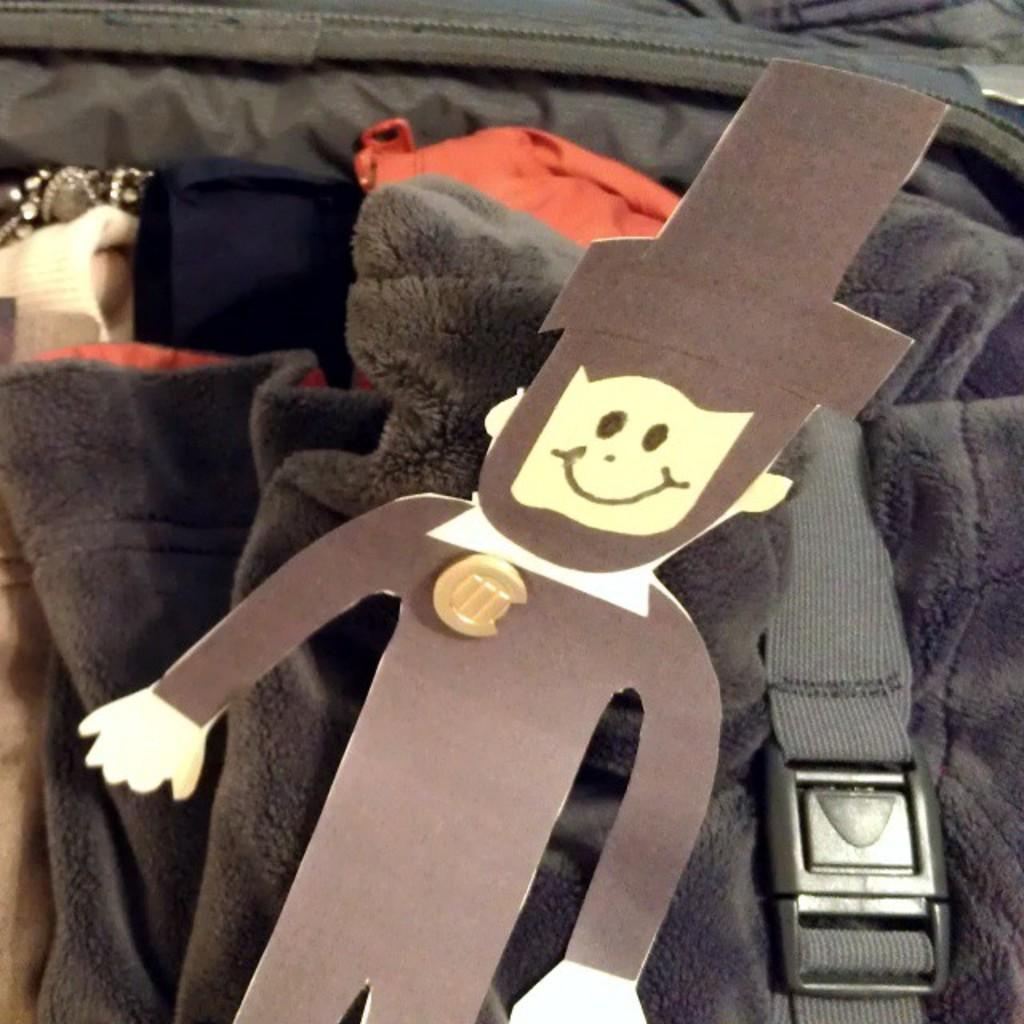What is the main subject of the image? The main subject of the image is a paper cutting of a man. What items can be seen in the luggage? There are sweaters and dresses packed in a suitcase. What feature is attached to the items in the luggage? A seat belt is attached to the items in the luggage. What hobbies does the man in the paper cutting have? The image does not provide information about the man's hobbies, as it only shows a paper cutting of him. 